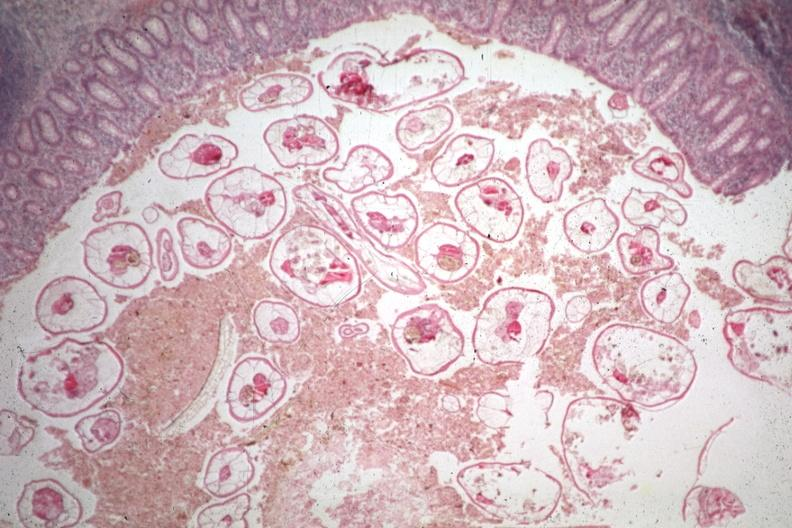s pinworm present?
Answer the question using a single word or phrase. Yes 